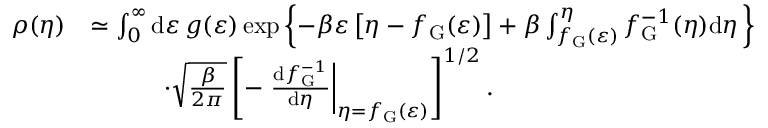<formula> <loc_0><loc_0><loc_500><loc_500>\begin{array} { r l } { \rho ( \eta ) } & { \simeq \int _ { 0 } ^ { \infty } d \varepsilon \, g ( \varepsilon ) \exp \left \{ - \beta \varepsilon \left [ \eta - f _ { G } ( \varepsilon ) \right ] + \beta \int _ { f _ { G } ( \varepsilon ) } ^ { \eta } f _ { G } ^ { - 1 } ( \eta ) d \eta \, \right \} } \\ & { \quad \cdot \sqrt { \frac { \beta } { 2 \pi } } \left [ - \frac { d f _ { G } ^ { - 1 } } { d \eta } \right | _ { \eta = f _ { G } ( \varepsilon ) } \right ] ^ { 1 / 2 } . } \end{array}</formula> 